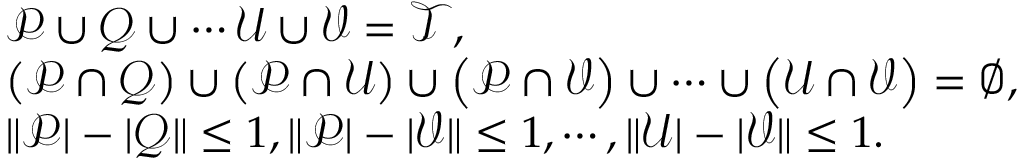Convert formula to latex. <formula><loc_0><loc_0><loc_500><loc_500>\begin{array} { r l } & { \mathcal { P } \cup \mathcal { Q } \cup \cdots \mathcal { U } \cup \mathcal { V } = \mathcal { T } , } \\ & { \left ( \mathcal { P } \cap \mathcal { Q } \right ) \cup \left ( \mathcal { P } \cap \mathcal { U } \right ) \cup \left ( \mathcal { P } \cap \mathcal { V } \right ) \cup \cdots \cup \left ( \mathcal { U } \cap \mathcal { V } \right ) = \varnothing , } \\ & { \| \mathcal { P } | - | \mathcal { Q } \| \leq 1 , \| \mathcal { P } | - | \mathcal { V } \| \leq 1 , \cdots , \| \mathcal { U } | - | \mathcal { V } \| \leq 1 . } \end{array}</formula> 